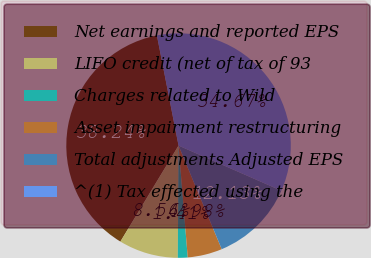Convert chart to OTSL. <chart><loc_0><loc_0><loc_500><loc_500><pie_chart><fcel>Net earnings and reported EPS<fcel>LIFO credit (net of tax of 93<fcel>Charges related to Wild<fcel>Asset impairment restructuring<fcel>Total adjustments Adjusted EPS<fcel>^(1) Tax effected using the<nl><fcel>38.24%<fcel>8.56%<fcel>1.41%<fcel>4.98%<fcel>12.13%<fcel>34.67%<nl></chart> 